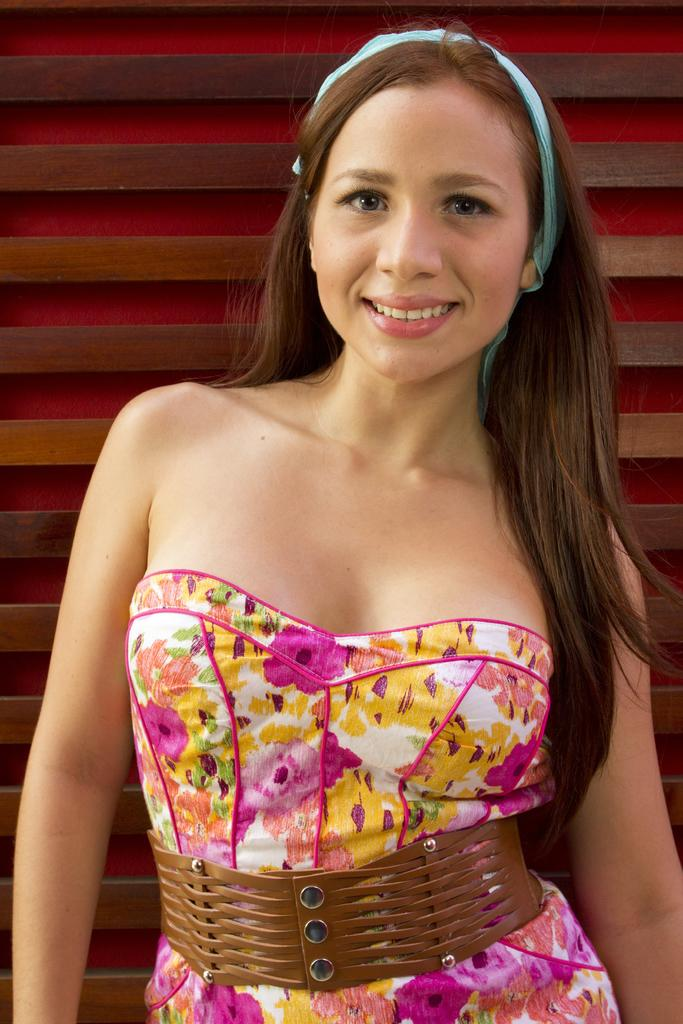Who is the main subject in the image? There is a woman in the image. What is the woman doing in the image? The woman is standing and smiling. What can be seen in the background of the image? There is a wall in the background of the image. What type of juice is the woman holding in the image? There is no juice present in the image; the woman is not holding anything. 